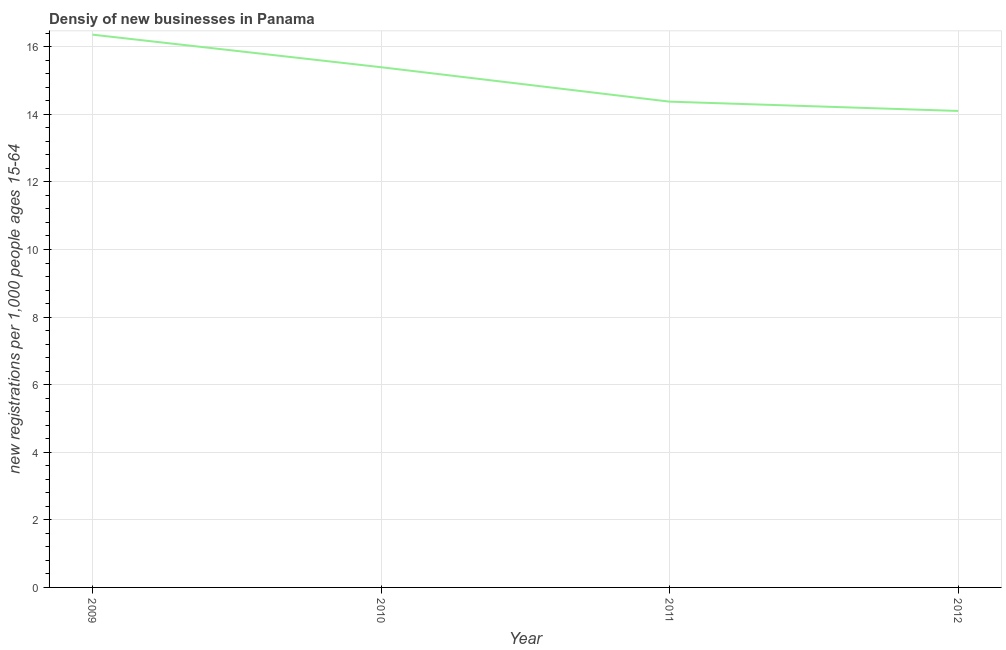What is the density of new business in 2011?
Provide a short and direct response. 14.38. Across all years, what is the maximum density of new business?
Keep it short and to the point. 16.36. Across all years, what is the minimum density of new business?
Offer a very short reply. 14.1. In which year was the density of new business maximum?
Offer a very short reply. 2009. In which year was the density of new business minimum?
Offer a very short reply. 2012. What is the sum of the density of new business?
Provide a succinct answer. 60.23. What is the difference between the density of new business in 2009 and 2010?
Offer a very short reply. 0.96. What is the average density of new business per year?
Your answer should be very brief. 15.06. What is the median density of new business?
Offer a terse response. 14.88. In how many years, is the density of new business greater than 4.8 ?
Provide a short and direct response. 4. Do a majority of the years between 2010 and 2012 (inclusive) have density of new business greater than 12.4 ?
Offer a very short reply. Yes. What is the ratio of the density of new business in 2009 to that in 2011?
Ensure brevity in your answer.  1.14. What is the difference between the highest and the second highest density of new business?
Your response must be concise. 0.96. What is the difference between the highest and the lowest density of new business?
Your answer should be compact. 2.26. Does the density of new business monotonically increase over the years?
Keep it short and to the point. No. What is the difference between two consecutive major ticks on the Y-axis?
Provide a short and direct response. 2. Does the graph contain any zero values?
Provide a short and direct response. No. What is the title of the graph?
Keep it short and to the point. Densiy of new businesses in Panama. What is the label or title of the Y-axis?
Offer a very short reply. New registrations per 1,0 people ages 15-64. What is the new registrations per 1,000 people ages 15-64 in 2009?
Offer a very short reply. 16.36. What is the new registrations per 1,000 people ages 15-64 of 2010?
Provide a short and direct response. 15.39. What is the new registrations per 1,000 people ages 15-64 in 2011?
Your response must be concise. 14.38. What is the new registrations per 1,000 people ages 15-64 in 2012?
Provide a short and direct response. 14.1. What is the difference between the new registrations per 1,000 people ages 15-64 in 2009 and 2010?
Provide a succinct answer. 0.96. What is the difference between the new registrations per 1,000 people ages 15-64 in 2009 and 2011?
Make the answer very short. 1.98. What is the difference between the new registrations per 1,000 people ages 15-64 in 2009 and 2012?
Your answer should be compact. 2.26. What is the difference between the new registrations per 1,000 people ages 15-64 in 2010 and 2011?
Your answer should be compact. 1.02. What is the difference between the new registrations per 1,000 people ages 15-64 in 2010 and 2012?
Provide a succinct answer. 1.29. What is the difference between the new registrations per 1,000 people ages 15-64 in 2011 and 2012?
Ensure brevity in your answer.  0.28. What is the ratio of the new registrations per 1,000 people ages 15-64 in 2009 to that in 2010?
Provide a succinct answer. 1.06. What is the ratio of the new registrations per 1,000 people ages 15-64 in 2009 to that in 2011?
Provide a succinct answer. 1.14. What is the ratio of the new registrations per 1,000 people ages 15-64 in 2009 to that in 2012?
Provide a short and direct response. 1.16. What is the ratio of the new registrations per 1,000 people ages 15-64 in 2010 to that in 2011?
Keep it short and to the point. 1.07. What is the ratio of the new registrations per 1,000 people ages 15-64 in 2010 to that in 2012?
Your response must be concise. 1.09. What is the ratio of the new registrations per 1,000 people ages 15-64 in 2011 to that in 2012?
Your answer should be compact. 1.02. 